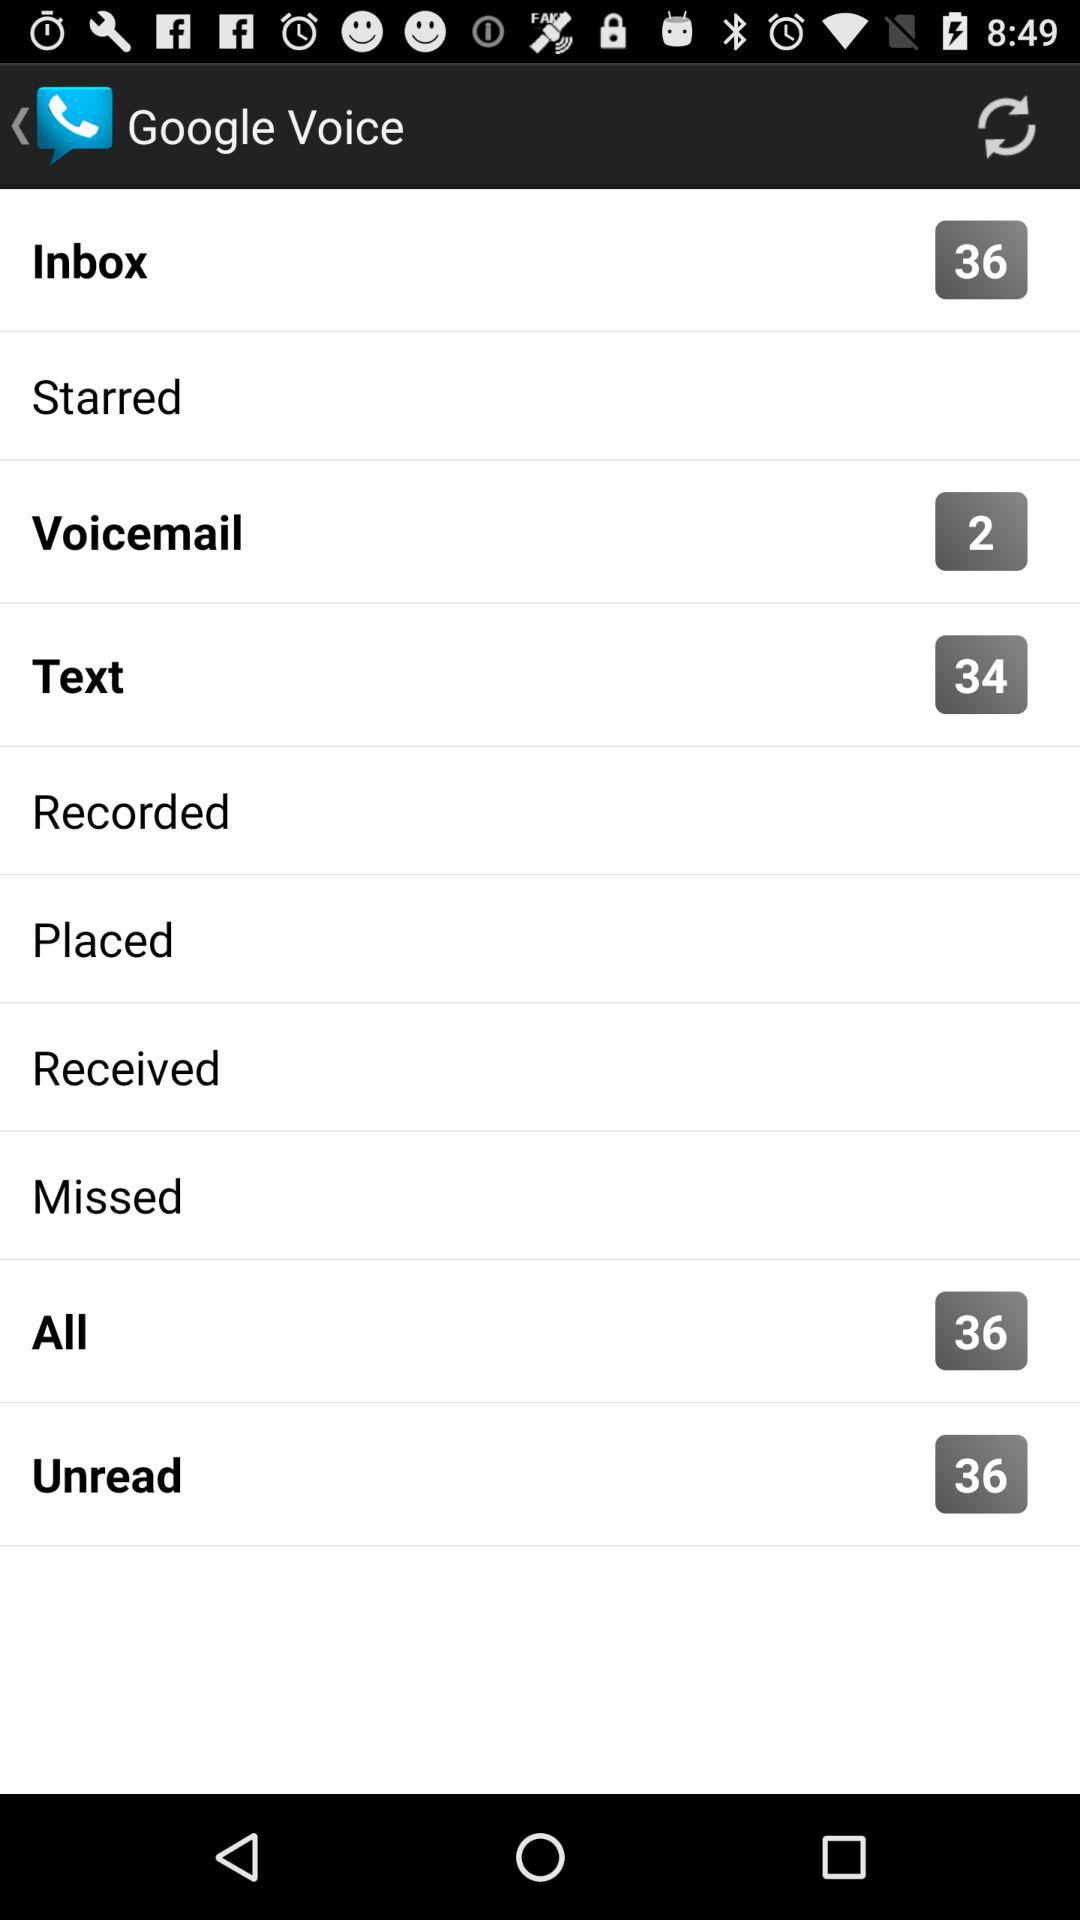How many messages are there in the inbox? There are 36 messages in the inbox. 